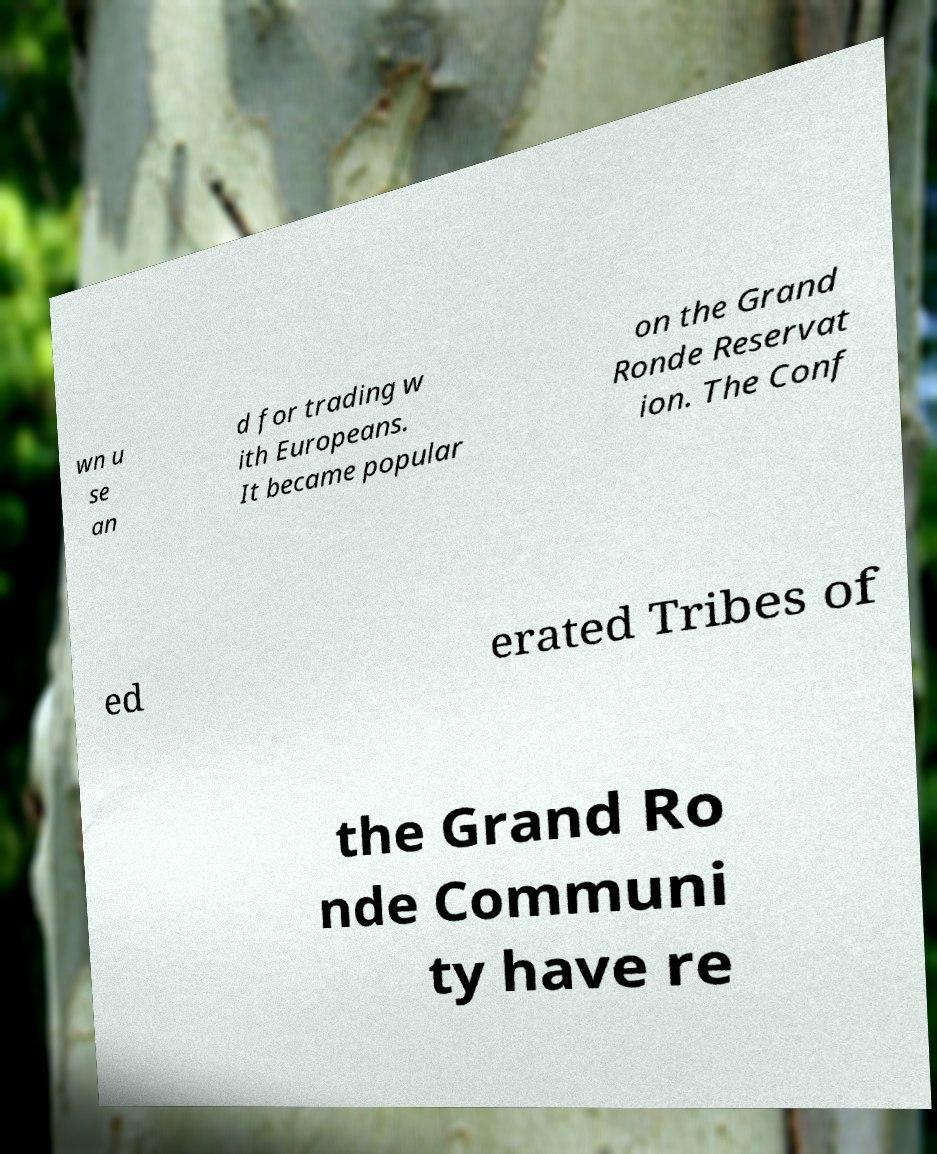Could you assist in decoding the text presented in this image and type it out clearly? wn u se an d for trading w ith Europeans. It became popular on the Grand Ronde Reservat ion. The Conf ed erated Tribes of the Grand Ro nde Communi ty have re 